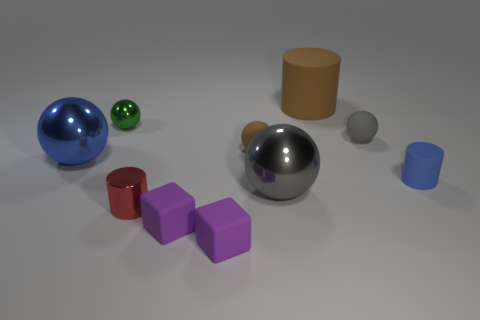Subtract all small cylinders. How many cylinders are left? 1 Subtract 1 cylinders. How many cylinders are left? 2 Subtract all brown spheres. How many spheres are left? 4 Subtract all cyan balls. Subtract all red cylinders. How many balls are left? 5 Subtract all cylinders. How many objects are left? 7 Add 1 large brown matte objects. How many large brown matte objects exist? 2 Subtract 0 gray blocks. How many objects are left? 10 Subtract all blue shiny objects. Subtract all tiny green objects. How many objects are left? 8 Add 8 green metal objects. How many green metal objects are left? 9 